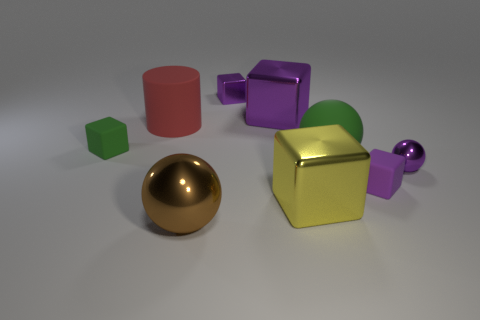Subtract all gray spheres. How many purple blocks are left? 3 Subtract all cyan blocks. Subtract all gray balls. How many blocks are left? 5 Add 1 matte objects. How many objects exist? 10 Subtract all cylinders. How many objects are left? 8 Subtract all tiny green balls. Subtract all tiny rubber objects. How many objects are left? 7 Add 8 purple rubber blocks. How many purple rubber blocks are left? 9 Add 7 big yellow metal objects. How many big yellow metal objects exist? 8 Subtract 1 green blocks. How many objects are left? 8 